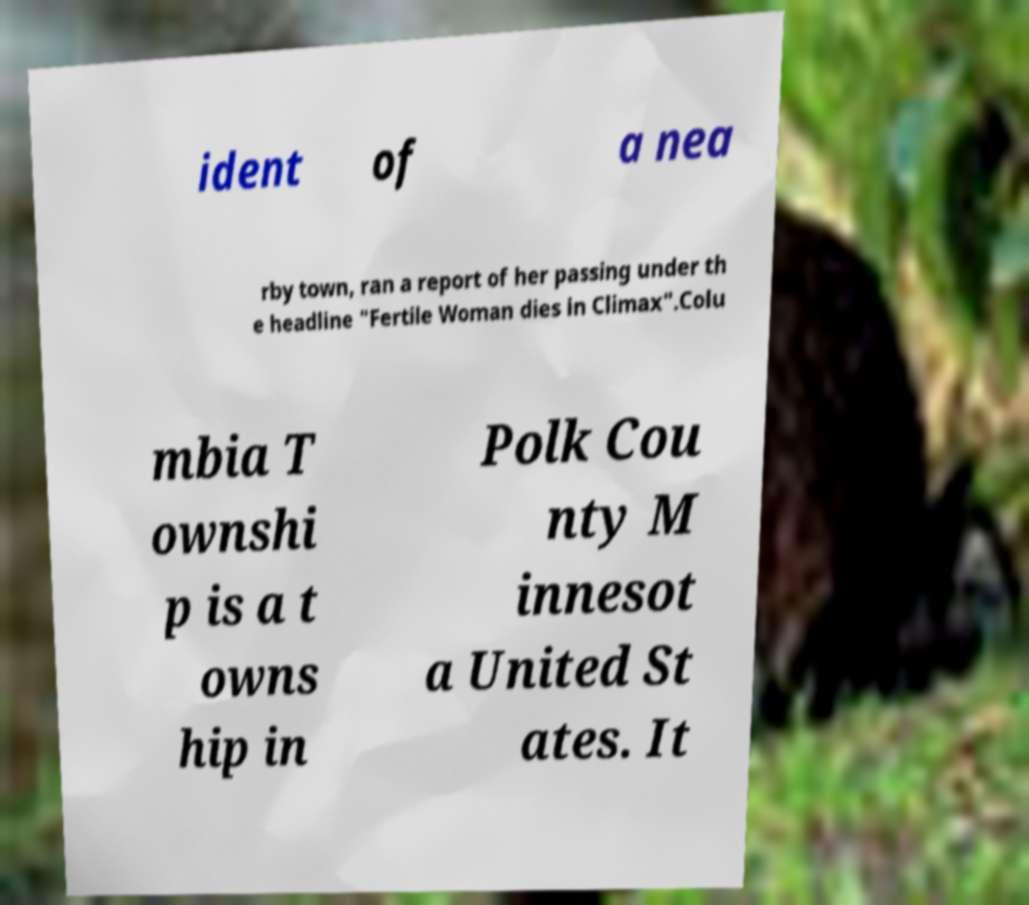Please read and relay the text visible in this image. What does it say? ident of a nea rby town, ran a report of her passing under th e headline "Fertile Woman dies in Climax".Colu mbia T ownshi p is a t owns hip in Polk Cou nty M innesot a United St ates. It 